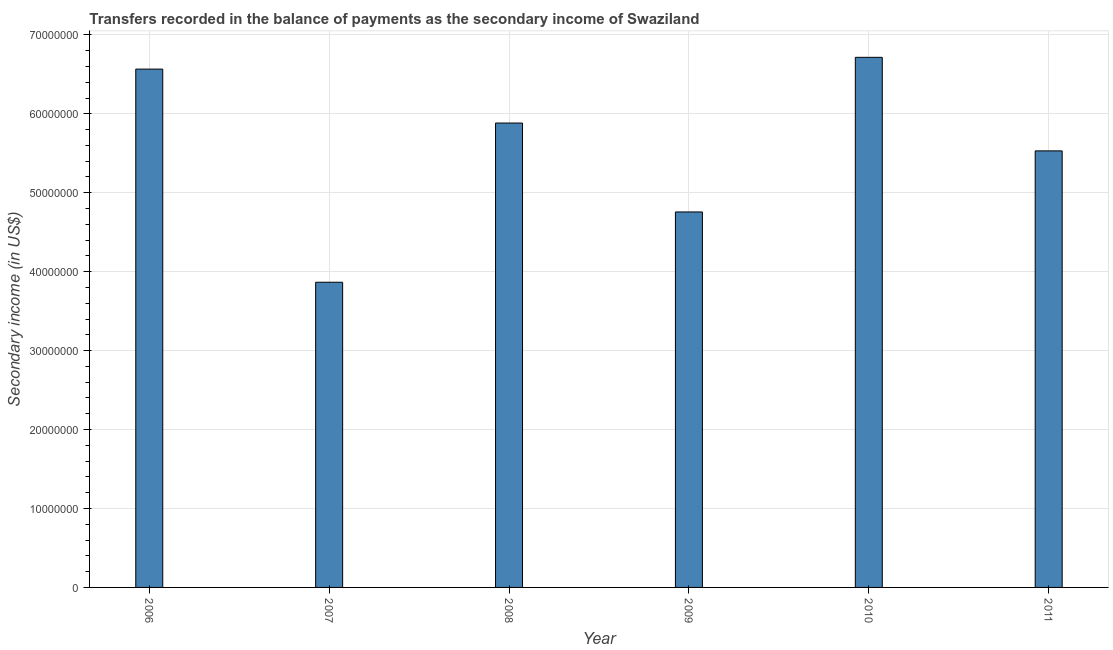Does the graph contain any zero values?
Your answer should be compact. No. Does the graph contain grids?
Provide a succinct answer. Yes. What is the title of the graph?
Your answer should be compact. Transfers recorded in the balance of payments as the secondary income of Swaziland. What is the label or title of the X-axis?
Your answer should be compact. Year. What is the label or title of the Y-axis?
Provide a short and direct response. Secondary income (in US$). What is the amount of secondary income in 2009?
Your response must be concise. 4.76e+07. Across all years, what is the maximum amount of secondary income?
Your answer should be very brief. 6.72e+07. Across all years, what is the minimum amount of secondary income?
Your response must be concise. 3.87e+07. In which year was the amount of secondary income minimum?
Offer a very short reply. 2007. What is the sum of the amount of secondary income?
Give a very brief answer. 3.33e+08. What is the difference between the amount of secondary income in 2009 and 2010?
Your answer should be very brief. -1.96e+07. What is the average amount of secondary income per year?
Offer a terse response. 5.55e+07. What is the median amount of secondary income?
Your answer should be very brief. 5.71e+07. Do a majority of the years between 2009 and 2010 (inclusive) have amount of secondary income greater than 16000000 US$?
Your answer should be compact. Yes. What is the ratio of the amount of secondary income in 2010 to that in 2011?
Ensure brevity in your answer.  1.21. Is the amount of secondary income in 2006 less than that in 2008?
Your answer should be compact. No. Is the difference between the amount of secondary income in 2009 and 2010 greater than the difference between any two years?
Offer a very short reply. No. What is the difference between the highest and the second highest amount of secondary income?
Provide a short and direct response. 1.49e+06. Is the sum of the amount of secondary income in 2006 and 2009 greater than the maximum amount of secondary income across all years?
Provide a succinct answer. Yes. What is the difference between the highest and the lowest amount of secondary income?
Offer a terse response. 2.85e+07. How many bars are there?
Offer a terse response. 6. Are all the bars in the graph horizontal?
Provide a succinct answer. No. Are the values on the major ticks of Y-axis written in scientific E-notation?
Your answer should be very brief. No. What is the Secondary income (in US$) in 2006?
Your answer should be compact. 6.57e+07. What is the Secondary income (in US$) in 2007?
Keep it short and to the point. 3.87e+07. What is the Secondary income (in US$) of 2008?
Provide a short and direct response. 5.88e+07. What is the Secondary income (in US$) of 2009?
Offer a very short reply. 4.76e+07. What is the Secondary income (in US$) of 2010?
Make the answer very short. 6.72e+07. What is the Secondary income (in US$) of 2011?
Keep it short and to the point. 5.53e+07. What is the difference between the Secondary income (in US$) in 2006 and 2007?
Ensure brevity in your answer.  2.70e+07. What is the difference between the Secondary income (in US$) in 2006 and 2008?
Give a very brief answer. 6.83e+06. What is the difference between the Secondary income (in US$) in 2006 and 2009?
Offer a terse response. 1.81e+07. What is the difference between the Secondary income (in US$) in 2006 and 2010?
Ensure brevity in your answer.  -1.49e+06. What is the difference between the Secondary income (in US$) in 2006 and 2011?
Give a very brief answer. 1.04e+07. What is the difference between the Secondary income (in US$) in 2007 and 2008?
Offer a very short reply. -2.02e+07. What is the difference between the Secondary income (in US$) in 2007 and 2009?
Your answer should be compact. -8.91e+06. What is the difference between the Secondary income (in US$) in 2007 and 2010?
Keep it short and to the point. -2.85e+07. What is the difference between the Secondary income (in US$) in 2007 and 2011?
Give a very brief answer. -1.66e+07. What is the difference between the Secondary income (in US$) in 2008 and 2009?
Keep it short and to the point. 1.13e+07. What is the difference between the Secondary income (in US$) in 2008 and 2010?
Offer a very short reply. -8.32e+06. What is the difference between the Secondary income (in US$) in 2008 and 2011?
Provide a succinct answer. 3.53e+06. What is the difference between the Secondary income (in US$) in 2009 and 2010?
Offer a terse response. -1.96e+07. What is the difference between the Secondary income (in US$) in 2009 and 2011?
Offer a very short reply. -7.74e+06. What is the difference between the Secondary income (in US$) in 2010 and 2011?
Offer a terse response. 1.19e+07. What is the ratio of the Secondary income (in US$) in 2006 to that in 2007?
Keep it short and to the point. 1.7. What is the ratio of the Secondary income (in US$) in 2006 to that in 2008?
Your answer should be compact. 1.12. What is the ratio of the Secondary income (in US$) in 2006 to that in 2009?
Your answer should be very brief. 1.38. What is the ratio of the Secondary income (in US$) in 2006 to that in 2011?
Provide a succinct answer. 1.19. What is the ratio of the Secondary income (in US$) in 2007 to that in 2008?
Your answer should be compact. 0.66. What is the ratio of the Secondary income (in US$) in 2007 to that in 2009?
Provide a short and direct response. 0.81. What is the ratio of the Secondary income (in US$) in 2007 to that in 2010?
Provide a succinct answer. 0.58. What is the ratio of the Secondary income (in US$) in 2007 to that in 2011?
Offer a very short reply. 0.7. What is the ratio of the Secondary income (in US$) in 2008 to that in 2009?
Ensure brevity in your answer.  1.24. What is the ratio of the Secondary income (in US$) in 2008 to that in 2010?
Give a very brief answer. 0.88. What is the ratio of the Secondary income (in US$) in 2008 to that in 2011?
Offer a terse response. 1.06. What is the ratio of the Secondary income (in US$) in 2009 to that in 2010?
Offer a terse response. 0.71. What is the ratio of the Secondary income (in US$) in 2009 to that in 2011?
Keep it short and to the point. 0.86. What is the ratio of the Secondary income (in US$) in 2010 to that in 2011?
Your answer should be compact. 1.21. 